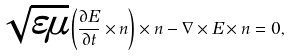Convert formula to latex. <formula><loc_0><loc_0><loc_500><loc_500>\sqrt { \varepsilon \mu } \left ( \frac { \partial E } { \partial t } \times n \right ) \times n - \nabla \times E \times n = 0 ,</formula> 